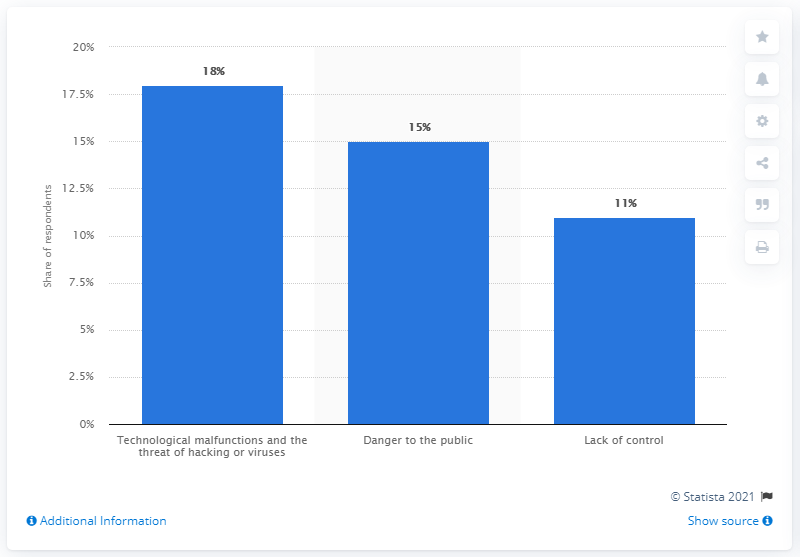Give some essential details in this illustration. In November 2014, the most commonly perceived disadvantages among respondents were technological malfunctions and the threat of hacking or viruses. 